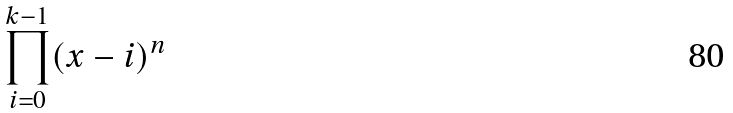Convert formula to latex. <formula><loc_0><loc_0><loc_500><loc_500>\prod _ { i = 0 } ^ { k - 1 } ( x - i ) ^ { n }</formula> 